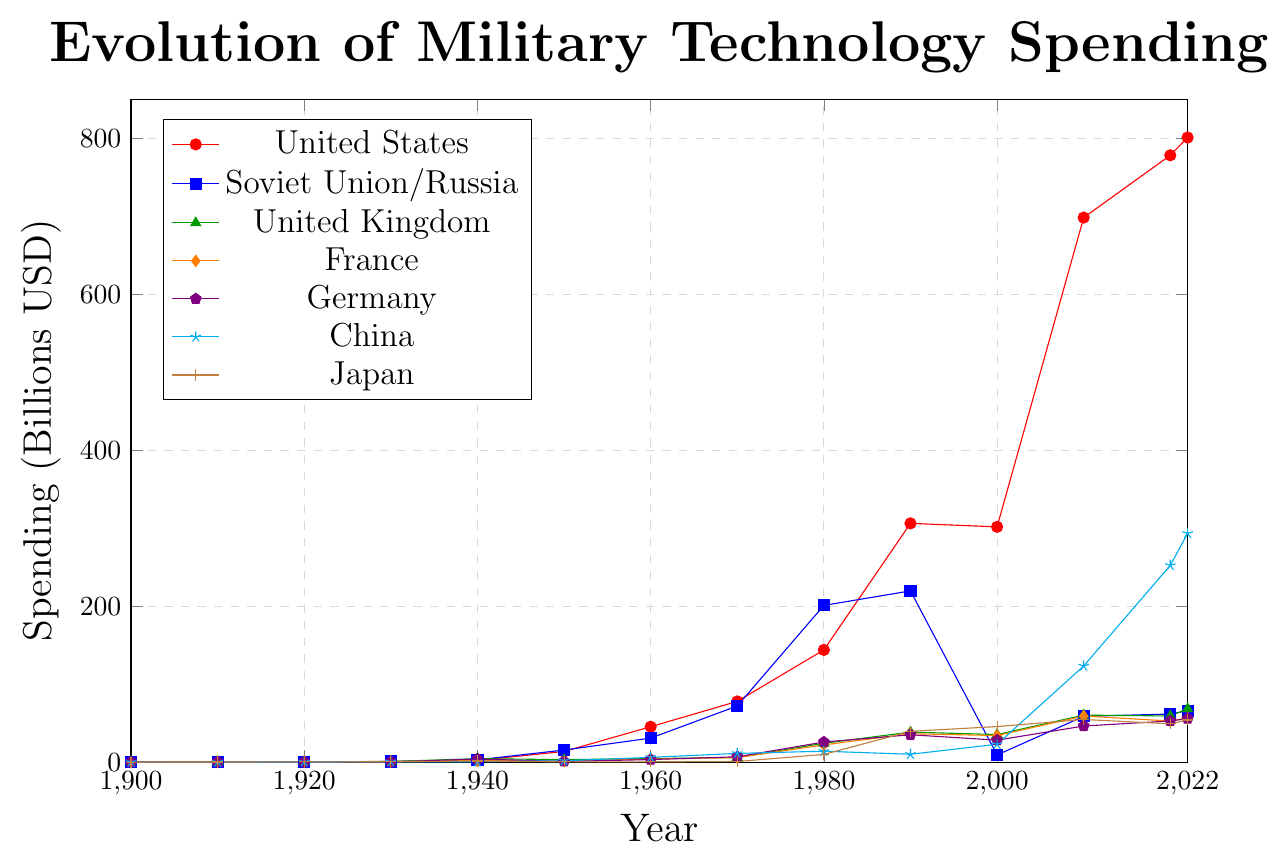What year did the United States surpass 100 billion USD in military technology spending? To find out the year the United States surpassed 100 billion USD, look for the first year where its spending goes above 100 on the Y-axis. The data shows that the United States reached 143.9 billion in 1980.
Answer: 1980 Which country had the highest military technology spending in 1940? To determine the country with the highest spending in 1940, compare all the countries' spending values along the y-axis for that year. In 1940, the United Kingdom had the highest spending at 4.5 Billion USD.
Answer: United Kingdom How much more did China spend on military technology in 2022 compared to 2000? Calculate the difference between China's spending in 2022 and 2000. In the figure, China's spending in 2000 is 22.9 billion USD and in 2022 is 293.4 billion USD. The difference is 293.4 - 22.9 = 270.5 billion USD.
Answer: 270.5 billion USD Compare the military spending of the United Kingdom and Japan in 2010. Which is higher and by how much? To compare, look for both countries' values in 2010. The United Kingdom's spending is 60.3 billion USD, and Japan's spending is 54.7 billion USD. The United Kingdom spent 60.3 - 54.7 = 5.6 billion USD more than Japan.
Answer: United Kingdom by 5.6 billion USD What is the trend in military spending for Germany from 1950 to 2022? Review Germany's military spending data values from 1950 to 2022. The trend shows fluctuations: a minor dip from 1950(0.9) to 1960(3.3), a rise and peak in 1980(25.8), another peak in 1990(35.1), and then a steady increase reaching 55.8 billion USD by 2022.
Answer: Increasing overall with fluctuations Which country had the most significant increase in military spending from 1900 to 2022? By comparing initial and final values for each country in the figure, determine the increase for all. The United States grew from 0.1 billion USD in 1900 to 801 billion USD in 2022—an increase of 800.9 billion USD, making it the most significant increase.
Answer: United States Identify the period when Soviet Union/Russia's military spending dramatically decreased, clearly shown in the figure. Look for a period where Soviet Union/Russia's spending shows a steep decline. The spending drops notably from 1990 (219.6) to 2000 (9.2).
Answer: 1990 to 2000 Calculate the average annual military spending of France across the entire period shown. Sum up France's values from all shown years [0.2, 0.3, 0.5, 0.7, 2.0, 1.4, 3.9, 5.8, 22.1, 36.4, 34.1, 59.1, 52.7, 56.6], compute the total sum (275.8), then divide by the number of values (14). The average is 275.8/14 ≈ 19.7 billion USD.
Answer: 19.7 billion USD 